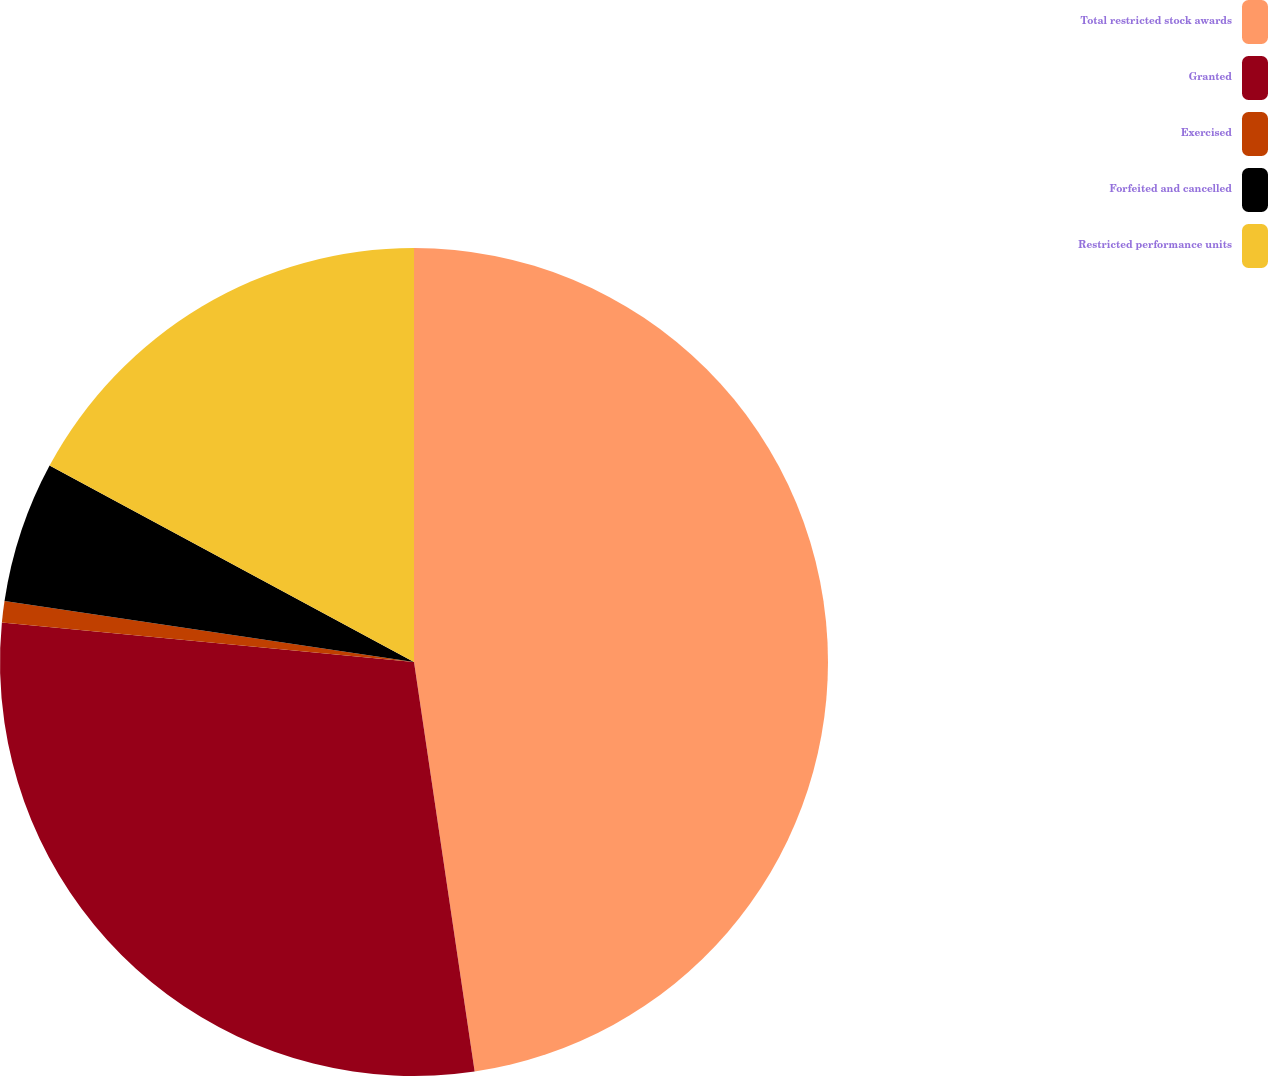Convert chart to OTSL. <chart><loc_0><loc_0><loc_500><loc_500><pie_chart><fcel>Total restricted stock awards<fcel>Granted<fcel>Exercised<fcel>Forfeited and cancelled<fcel>Restricted performance units<nl><fcel>47.66%<fcel>28.86%<fcel>0.83%<fcel>5.52%<fcel>17.13%<nl></chart> 